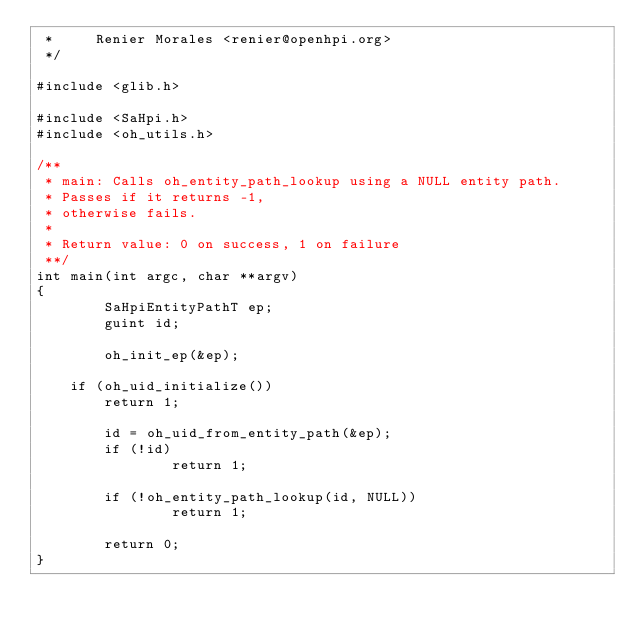Convert code to text. <code><loc_0><loc_0><loc_500><loc_500><_C_> *     Renier Morales <renier@openhpi.org>
 */

#include <glib.h>

#include <SaHpi.h>
#include <oh_utils.h>

/**
 * main: Calls oh_entity_path_lookup using a NULL entity path.
 * Passes if it returns -1,
 * otherwise fails.
 *
 * Return value: 0 on success, 1 on failure
 **/
int main(int argc, char **argv)
{
        SaHpiEntityPathT ep;
        guint id;

        oh_init_ep(&ep);

	if (oh_uid_initialize())
		return 1;

        id = oh_uid_from_entity_path(&ep);
        if (!id)
                return 1;

        if (!oh_entity_path_lookup(id, NULL))
                return 1;

        return 0;
}
</code> 